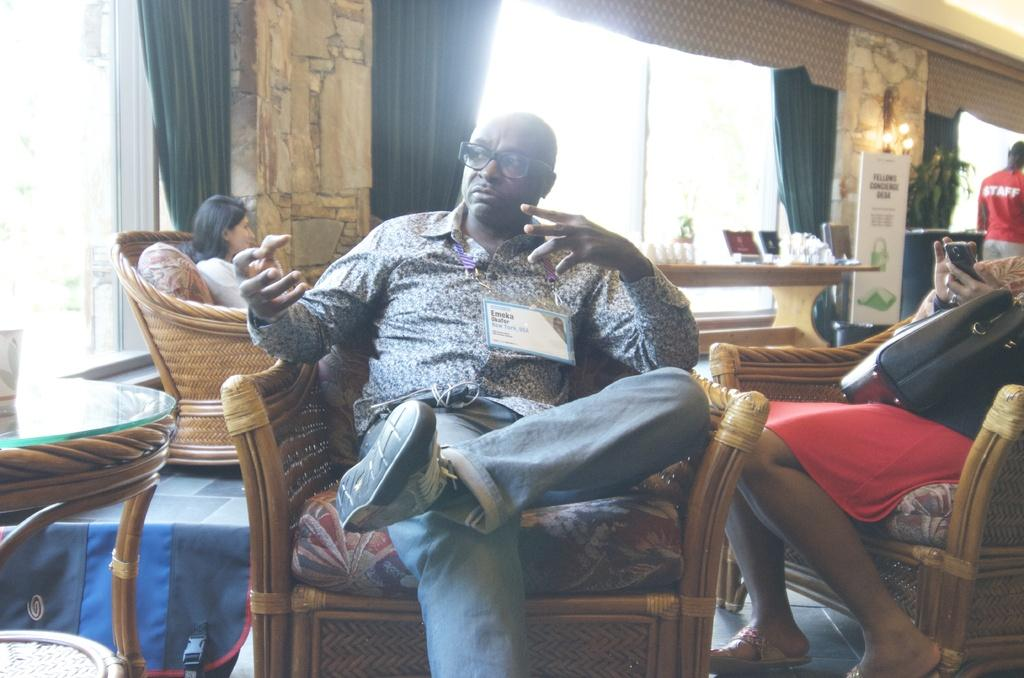What is the man in the image doing? The man is sitting on a chair in the image. What can be seen in the background of the image? There is a table, curtains, a wall, a poster, and lights in the background of the image. What type of art is the man creating with the pot in the image? There is no pot or art creation present in the image. What is the man's primary interest, as depicted in the image? The image does not provide information about the man's primary interest. 